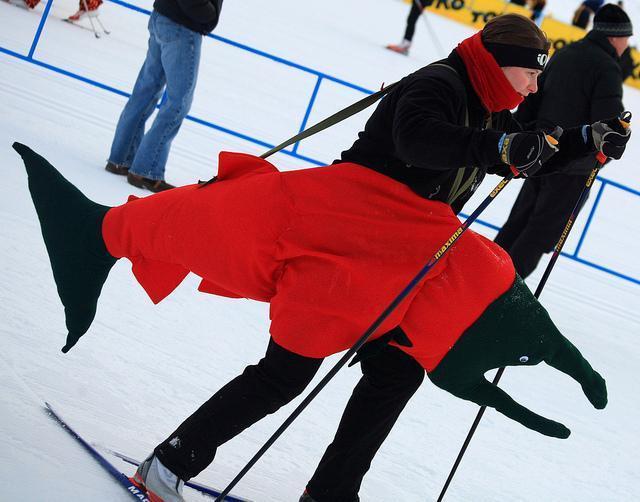How many people are there?
Give a very brief answer. 3. 